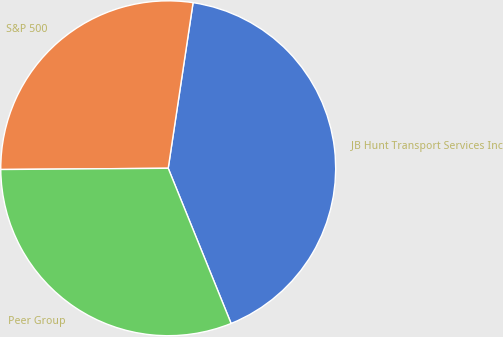Convert chart. <chart><loc_0><loc_0><loc_500><loc_500><pie_chart><fcel>JB Hunt Transport Services Inc<fcel>S&P 500<fcel>Peer Group<nl><fcel>41.5%<fcel>27.49%<fcel>31.01%<nl></chart> 